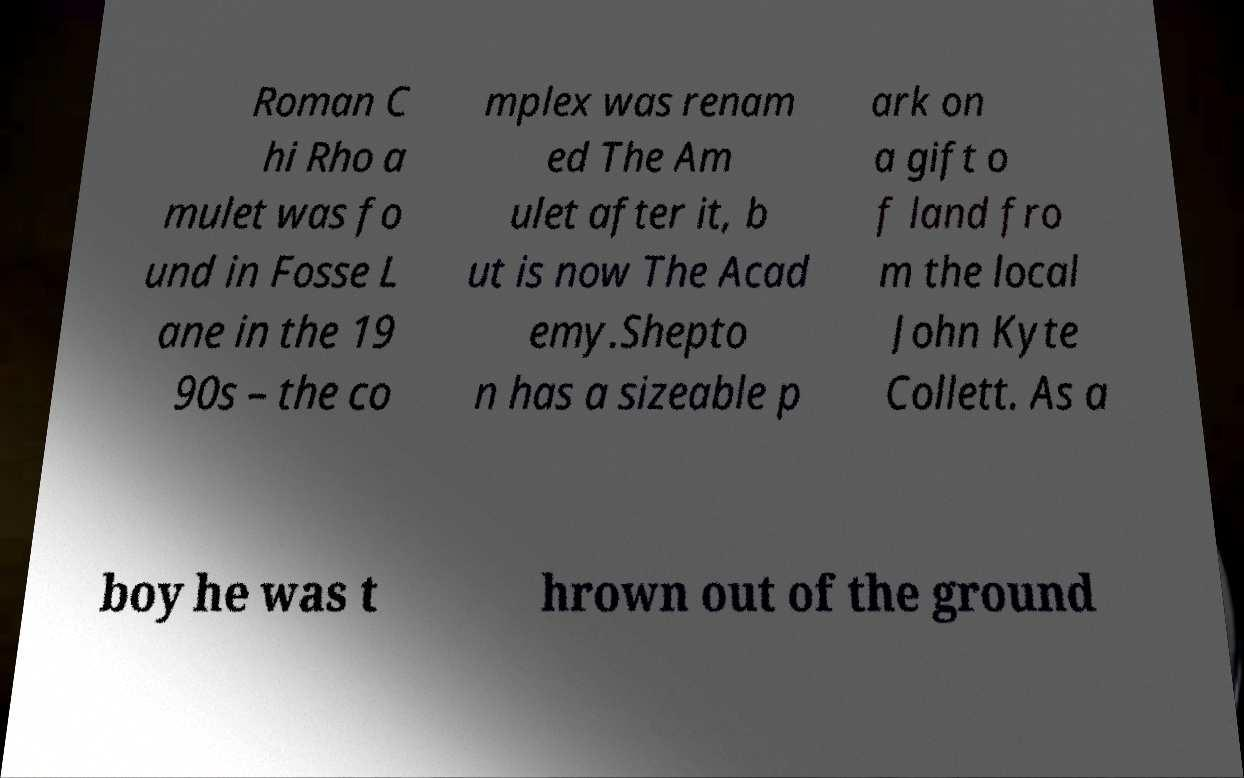Could you assist in decoding the text presented in this image and type it out clearly? Roman C hi Rho a mulet was fo und in Fosse L ane in the 19 90s – the co mplex was renam ed The Am ulet after it, b ut is now The Acad emy.Shepto n has a sizeable p ark on a gift o f land fro m the local John Kyte Collett. As a boy he was t hrown out of the ground 